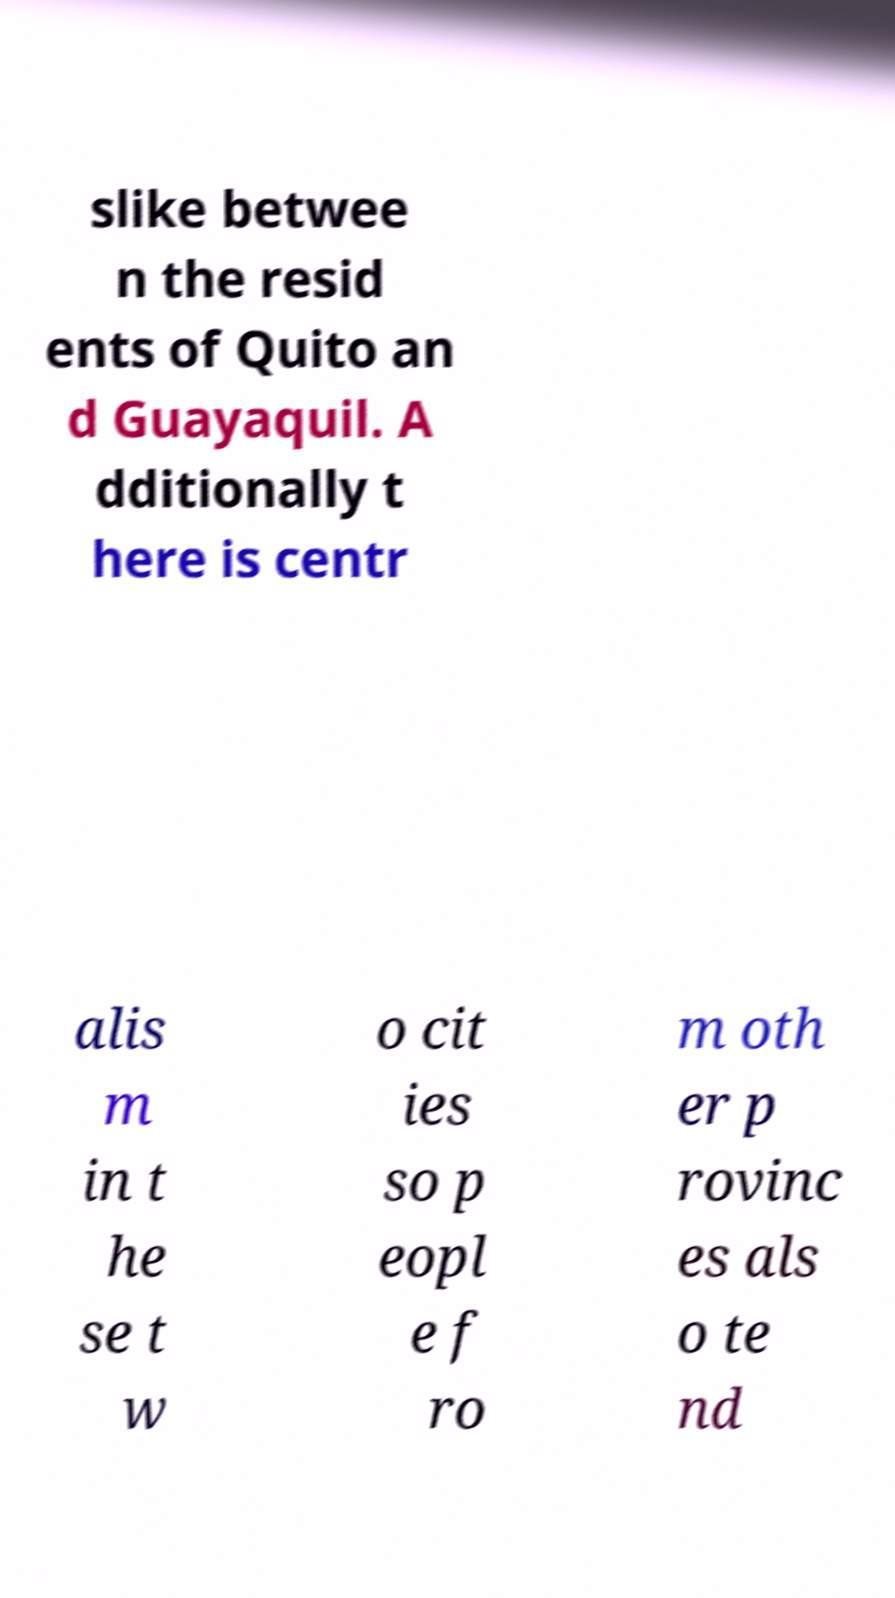Could you extract and type out the text from this image? slike betwee n the resid ents of Quito an d Guayaquil. A dditionally t here is centr alis m in t he se t w o cit ies so p eopl e f ro m oth er p rovinc es als o te nd 